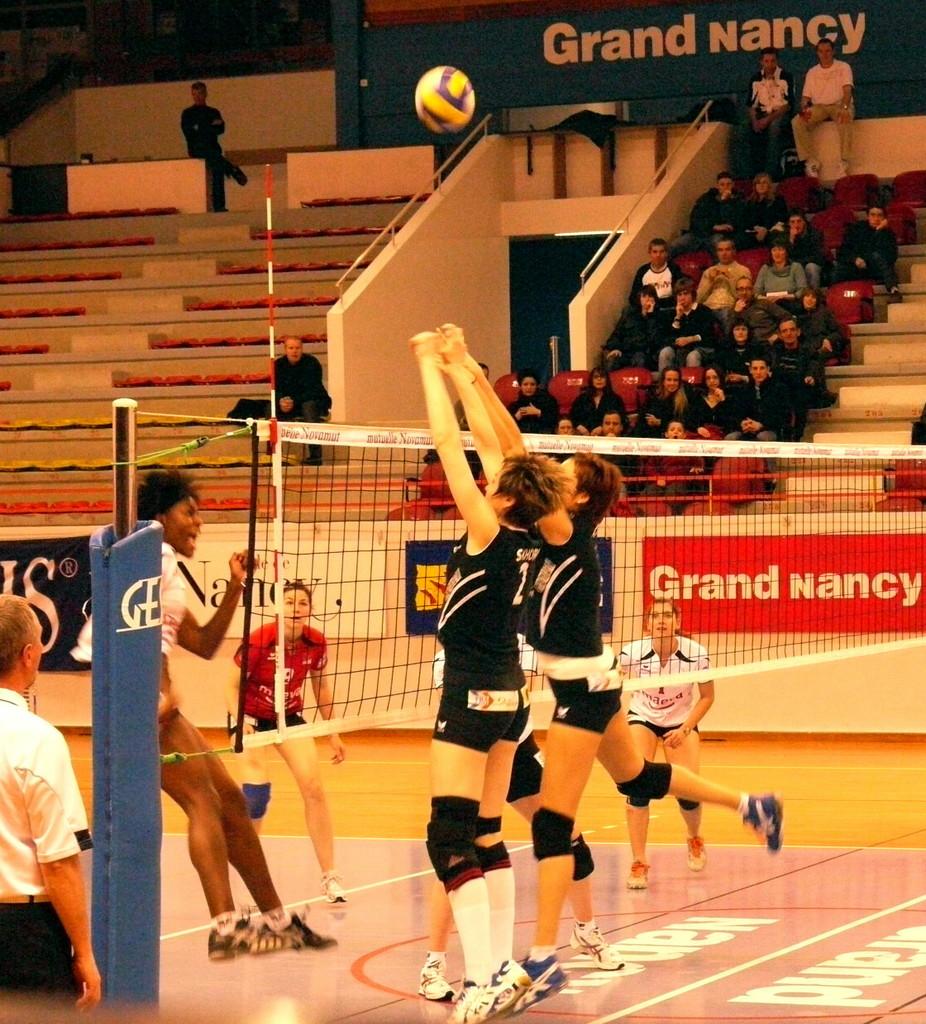What words are seen on the orange sign?
Offer a terse response. Grand nancy. This is volley ball game?
Ensure brevity in your answer.  Answering does not require reading text in the image. 